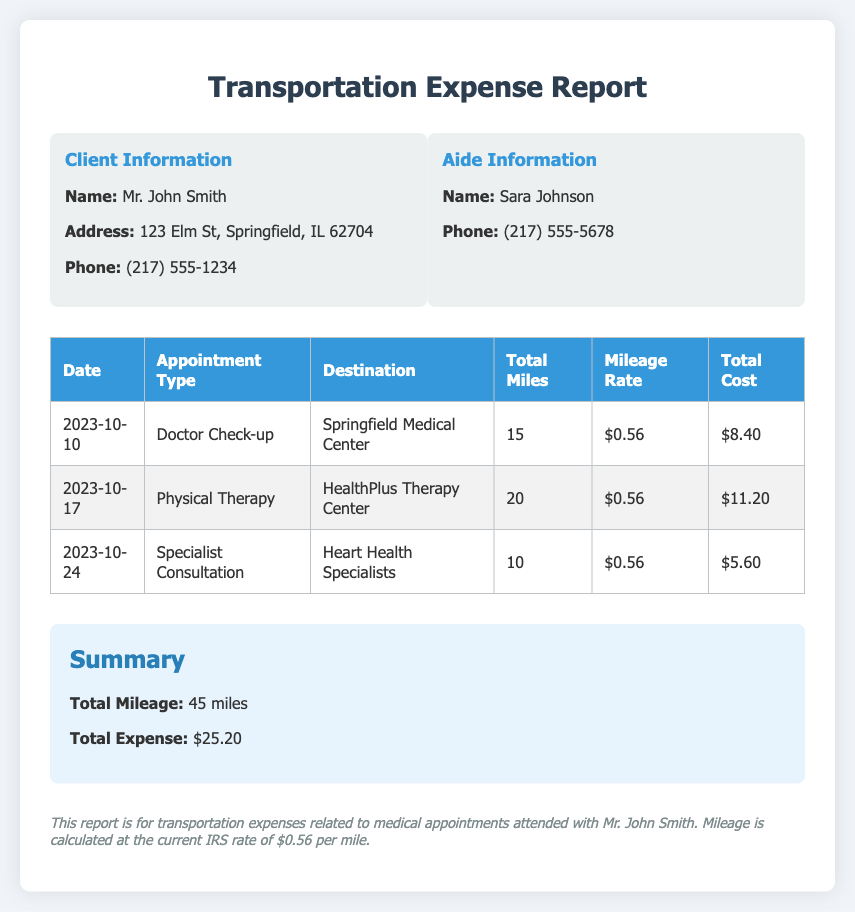What is the client's name? The client's name is provided in the "Client Information" section of the document.
Answer: Mr. John Smith What is the total mileage for medical appointments? The total mileage is summarized in the "Summary" section of the document, which is the sum of all miles traveled.
Answer: 45 miles What is the mileage rate used for calculations? The mileage rate is specifically mentioned in the table for each appointment and summarized in the notes.
Answer: $0.56 What was the appointment type on October 17, 2023? The date and corresponding appointment type are listed in the table for that date.
Answer: Physical Therapy What is the total expense reported? The total expense is calculated and shown in the "Summary" section of the document.
Answer: $25.20 Which facility was visited for the Doctor Check-up? The destination for the Doctor Check-up is provided in the table corresponding to the date.
Answer: Springfield Medical Center How many appointments are listed in the document? The total number of appointments can be counted from the rows in the table provided.
Answer: 3 What is the total cost for the Specialist Consultation? The specific total cost is recorded in the table under "Total Cost" for that appointment.
Answer: $5.60 What is the phone number of the aide? The aide's phone number is included in the "Aide Information" section of the document.
Answer: (217) 555-5678 